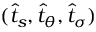Convert formula to latex. <formula><loc_0><loc_0><loc_500><loc_500>( \widehat { t } _ { s } , \widehat { t } _ { \theta } , \widehat { t } _ { \sigma } )</formula> 